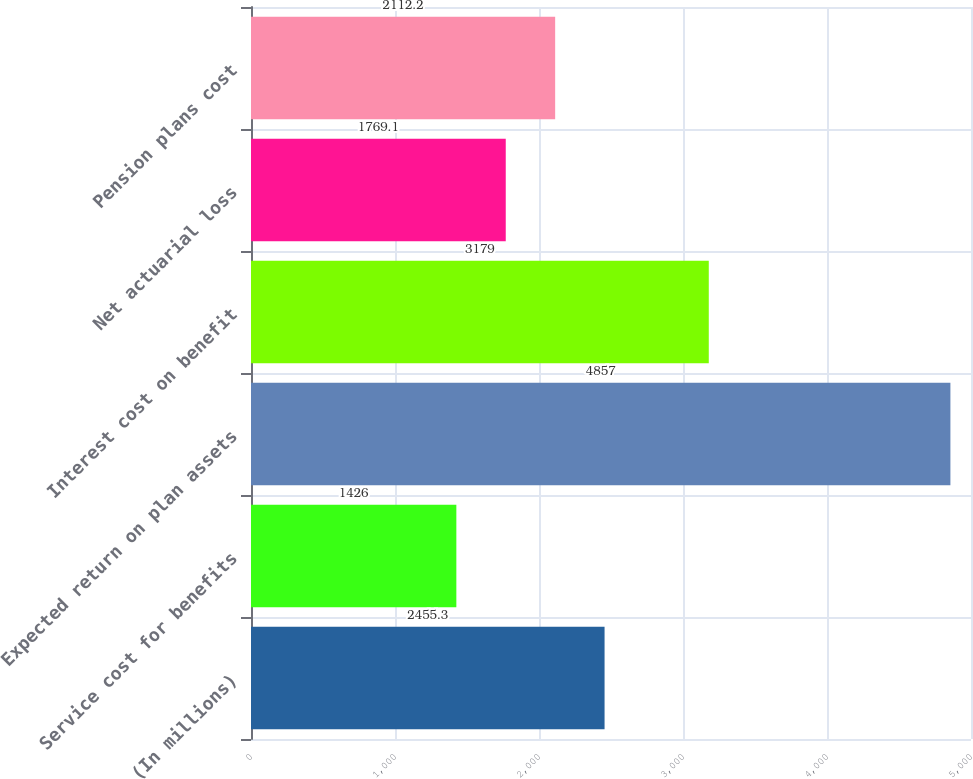Convert chart to OTSL. <chart><loc_0><loc_0><loc_500><loc_500><bar_chart><fcel>(In millions)<fcel>Service cost for benefits<fcel>Expected return on plan assets<fcel>Interest cost on benefit<fcel>Net actuarial loss<fcel>Pension plans cost<nl><fcel>2455.3<fcel>1426<fcel>4857<fcel>3179<fcel>1769.1<fcel>2112.2<nl></chart> 